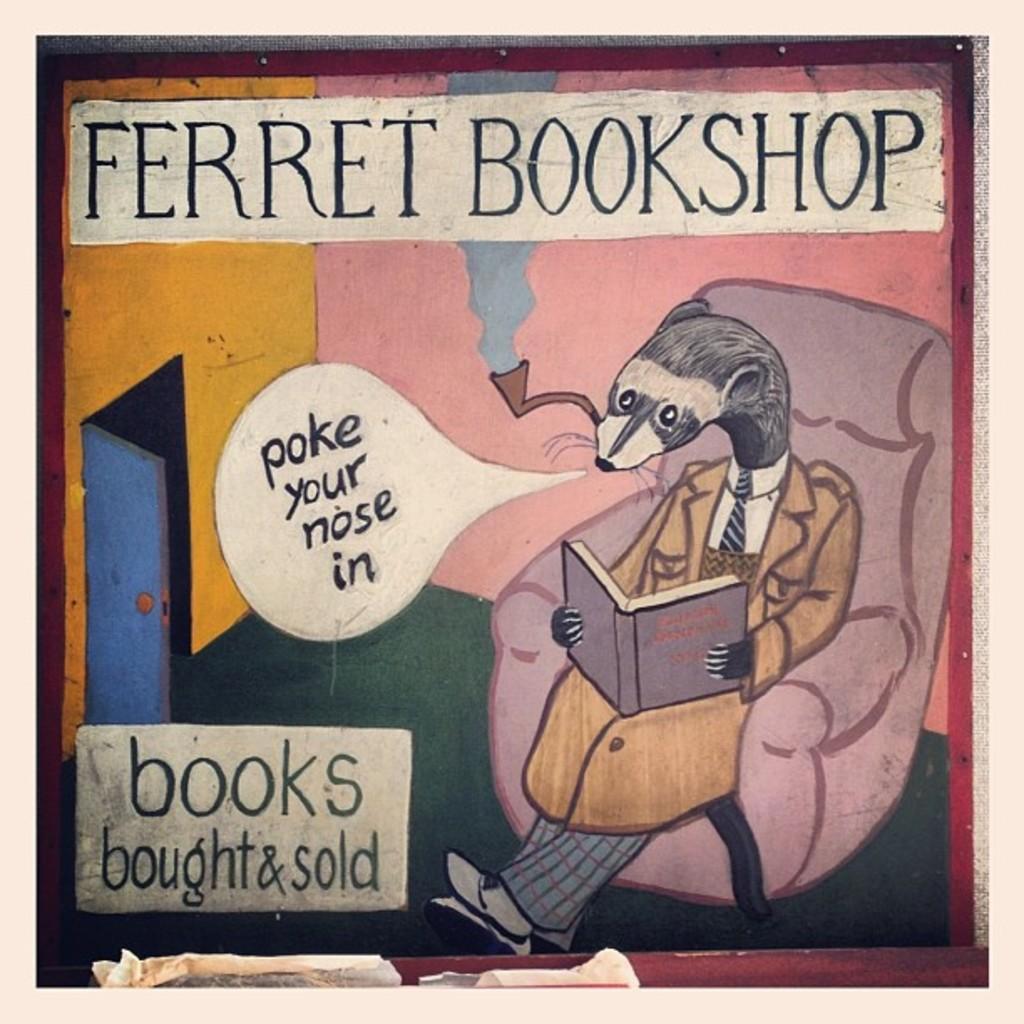How would you summarize this image in a sentence or two? In this image in the front there is a drawing of an object holding a book and there is a sofa which is pink in colour and there is a door which is blue in colour and there are some texts written on it. 